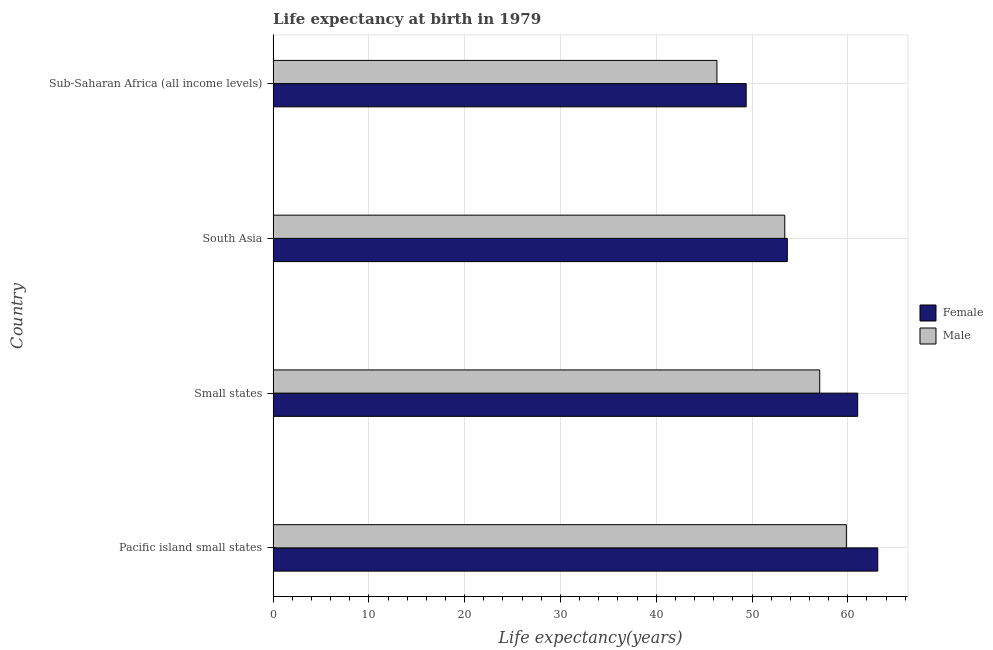How many different coloured bars are there?
Provide a succinct answer. 2. How many groups of bars are there?
Provide a short and direct response. 4. Are the number of bars per tick equal to the number of legend labels?
Ensure brevity in your answer.  Yes. How many bars are there on the 4th tick from the bottom?
Give a very brief answer. 2. What is the label of the 1st group of bars from the top?
Your answer should be compact. Sub-Saharan Africa (all income levels). What is the life expectancy(male) in Small states?
Provide a succinct answer. 57.07. Across all countries, what is the maximum life expectancy(male)?
Offer a terse response. 59.85. Across all countries, what is the minimum life expectancy(male)?
Keep it short and to the point. 46.34. In which country was the life expectancy(female) maximum?
Offer a terse response. Pacific island small states. In which country was the life expectancy(male) minimum?
Your response must be concise. Sub-Saharan Africa (all income levels). What is the total life expectancy(male) in the graph?
Give a very brief answer. 216.68. What is the difference between the life expectancy(male) in Pacific island small states and that in Sub-Saharan Africa (all income levels)?
Ensure brevity in your answer.  13.51. What is the difference between the life expectancy(male) in Sub-Saharan Africa (all income levels) and the life expectancy(female) in Small states?
Ensure brevity in your answer.  -14.69. What is the average life expectancy(male) per country?
Offer a very short reply. 54.17. What is the difference between the life expectancy(male) and life expectancy(female) in Small states?
Offer a very short reply. -3.96. In how many countries, is the life expectancy(male) greater than 46 years?
Offer a very short reply. 4. What is the ratio of the life expectancy(female) in Small states to that in South Asia?
Give a very brief answer. 1.14. Is the life expectancy(male) in Pacific island small states less than that in South Asia?
Your response must be concise. No. What is the difference between the highest and the second highest life expectancy(female)?
Your response must be concise. 2.1. What is the difference between the highest and the lowest life expectancy(male)?
Ensure brevity in your answer.  13.51. In how many countries, is the life expectancy(female) greater than the average life expectancy(female) taken over all countries?
Your answer should be compact. 2. Is the sum of the life expectancy(male) in South Asia and Sub-Saharan Africa (all income levels) greater than the maximum life expectancy(female) across all countries?
Offer a terse response. Yes. How many bars are there?
Keep it short and to the point. 8. Are all the bars in the graph horizontal?
Your answer should be very brief. Yes. How many countries are there in the graph?
Give a very brief answer. 4. Are the values on the major ticks of X-axis written in scientific E-notation?
Offer a very short reply. No. Does the graph contain grids?
Your response must be concise. Yes. How are the legend labels stacked?
Offer a terse response. Vertical. What is the title of the graph?
Provide a short and direct response. Life expectancy at birth in 1979. Does "Urban" appear as one of the legend labels in the graph?
Keep it short and to the point. No. What is the label or title of the X-axis?
Offer a very short reply. Life expectancy(years). What is the label or title of the Y-axis?
Your answer should be very brief. Country. What is the Life expectancy(years) of Female in Pacific island small states?
Provide a succinct answer. 63.13. What is the Life expectancy(years) in Male in Pacific island small states?
Your answer should be compact. 59.85. What is the Life expectancy(years) in Female in Small states?
Give a very brief answer. 61.03. What is the Life expectancy(years) of Male in Small states?
Provide a short and direct response. 57.07. What is the Life expectancy(years) in Female in South Asia?
Keep it short and to the point. 53.69. What is the Life expectancy(years) in Male in South Asia?
Offer a very short reply. 53.42. What is the Life expectancy(years) in Female in Sub-Saharan Africa (all income levels)?
Offer a terse response. 49.39. What is the Life expectancy(years) in Male in Sub-Saharan Africa (all income levels)?
Your response must be concise. 46.34. Across all countries, what is the maximum Life expectancy(years) in Female?
Offer a terse response. 63.13. Across all countries, what is the maximum Life expectancy(years) of Male?
Your answer should be compact. 59.85. Across all countries, what is the minimum Life expectancy(years) of Female?
Give a very brief answer. 49.39. Across all countries, what is the minimum Life expectancy(years) in Male?
Keep it short and to the point. 46.34. What is the total Life expectancy(years) in Female in the graph?
Give a very brief answer. 227.24. What is the total Life expectancy(years) of Male in the graph?
Ensure brevity in your answer.  216.68. What is the difference between the Life expectancy(years) in Female in Pacific island small states and that in Small states?
Make the answer very short. 2.09. What is the difference between the Life expectancy(years) in Male in Pacific island small states and that in Small states?
Provide a succinct answer. 2.78. What is the difference between the Life expectancy(years) of Female in Pacific island small states and that in South Asia?
Keep it short and to the point. 9.44. What is the difference between the Life expectancy(years) of Male in Pacific island small states and that in South Asia?
Your response must be concise. 6.43. What is the difference between the Life expectancy(years) of Female in Pacific island small states and that in Sub-Saharan Africa (all income levels)?
Provide a short and direct response. 13.73. What is the difference between the Life expectancy(years) of Male in Pacific island small states and that in Sub-Saharan Africa (all income levels)?
Ensure brevity in your answer.  13.51. What is the difference between the Life expectancy(years) of Female in Small states and that in South Asia?
Your answer should be very brief. 7.35. What is the difference between the Life expectancy(years) of Male in Small states and that in South Asia?
Give a very brief answer. 3.65. What is the difference between the Life expectancy(years) in Female in Small states and that in Sub-Saharan Africa (all income levels)?
Offer a very short reply. 11.64. What is the difference between the Life expectancy(years) of Male in Small states and that in Sub-Saharan Africa (all income levels)?
Offer a very short reply. 10.73. What is the difference between the Life expectancy(years) of Female in South Asia and that in Sub-Saharan Africa (all income levels)?
Keep it short and to the point. 4.29. What is the difference between the Life expectancy(years) of Male in South Asia and that in Sub-Saharan Africa (all income levels)?
Offer a terse response. 7.08. What is the difference between the Life expectancy(years) in Female in Pacific island small states and the Life expectancy(years) in Male in Small states?
Keep it short and to the point. 6.06. What is the difference between the Life expectancy(years) of Female in Pacific island small states and the Life expectancy(years) of Male in South Asia?
Your answer should be very brief. 9.71. What is the difference between the Life expectancy(years) of Female in Pacific island small states and the Life expectancy(years) of Male in Sub-Saharan Africa (all income levels)?
Provide a succinct answer. 16.79. What is the difference between the Life expectancy(years) of Female in Small states and the Life expectancy(years) of Male in South Asia?
Provide a succinct answer. 7.61. What is the difference between the Life expectancy(years) in Female in Small states and the Life expectancy(years) in Male in Sub-Saharan Africa (all income levels)?
Your answer should be very brief. 14.69. What is the difference between the Life expectancy(years) in Female in South Asia and the Life expectancy(years) in Male in Sub-Saharan Africa (all income levels)?
Keep it short and to the point. 7.35. What is the average Life expectancy(years) of Female per country?
Your answer should be very brief. 56.81. What is the average Life expectancy(years) in Male per country?
Provide a short and direct response. 54.17. What is the difference between the Life expectancy(years) in Female and Life expectancy(years) in Male in Pacific island small states?
Ensure brevity in your answer.  3.28. What is the difference between the Life expectancy(years) in Female and Life expectancy(years) in Male in Small states?
Ensure brevity in your answer.  3.96. What is the difference between the Life expectancy(years) of Female and Life expectancy(years) of Male in South Asia?
Make the answer very short. 0.27. What is the difference between the Life expectancy(years) in Female and Life expectancy(years) in Male in Sub-Saharan Africa (all income levels)?
Your answer should be compact. 3.05. What is the ratio of the Life expectancy(years) of Female in Pacific island small states to that in Small states?
Your response must be concise. 1.03. What is the ratio of the Life expectancy(years) in Male in Pacific island small states to that in Small states?
Your response must be concise. 1.05. What is the ratio of the Life expectancy(years) of Female in Pacific island small states to that in South Asia?
Make the answer very short. 1.18. What is the ratio of the Life expectancy(years) in Male in Pacific island small states to that in South Asia?
Give a very brief answer. 1.12. What is the ratio of the Life expectancy(years) of Female in Pacific island small states to that in Sub-Saharan Africa (all income levels)?
Your response must be concise. 1.28. What is the ratio of the Life expectancy(years) of Male in Pacific island small states to that in Sub-Saharan Africa (all income levels)?
Your response must be concise. 1.29. What is the ratio of the Life expectancy(years) in Female in Small states to that in South Asia?
Make the answer very short. 1.14. What is the ratio of the Life expectancy(years) of Male in Small states to that in South Asia?
Provide a short and direct response. 1.07. What is the ratio of the Life expectancy(years) of Female in Small states to that in Sub-Saharan Africa (all income levels)?
Ensure brevity in your answer.  1.24. What is the ratio of the Life expectancy(years) in Male in Small states to that in Sub-Saharan Africa (all income levels)?
Provide a short and direct response. 1.23. What is the ratio of the Life expectancy(years) in Female in South Asia to that in Sub-Saharan Africa (all income levels)?
Provide a short and direct response. 1.09. What is the ratio of the Life expectancy(years) of Male in South Asia to that in Sub-Saharan Africa (all income levels)?
Your answer should be compact. 1.15. What is the difference between the highest and the second highest Life expectancy(years) of Female?
Offer a terse response. 2.09. What is the difference between the highest and the second highest Life expectancy(years) of Male?
Provide a succinct answer. 2.78. What is the difference between the highest and the lowest Life expectancy(years) of Female?
Ensure brevity in your answer.  13.73. What is the difference between the highest and the lowest Life expectancy(years) in Male?
Ensure brevity in your answer.  13.51. 